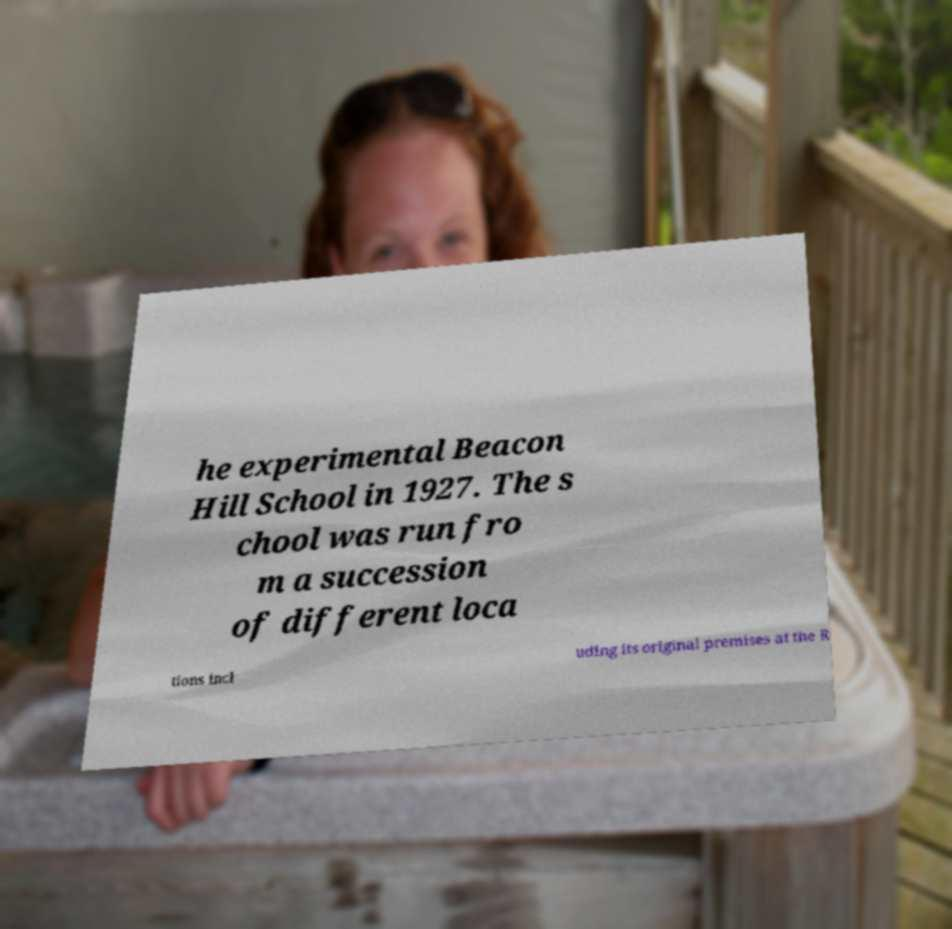For documentation purposes, I need the text within this image transcribed. Could you provide that? he experimental Beacon Hill School in 1927. The s chool was run fro m a succession of different loca tions incl uding its original premises at the R 